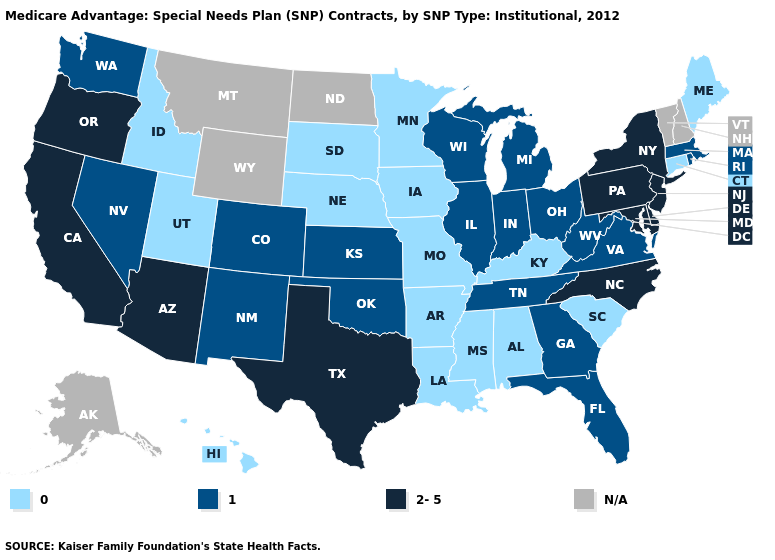What is the value of Nebraska?
Keep it brief. 0. What is the value of Mississippi?
Quick response, please. 0. Which states have the lowest value in the Northeast?
Be succinct. Connecticut, Maine. Name the states that have a value in the range 2-5?
Short answer required. Arizona, California, Delaware, Maryland, North Carolina, New Jersey, New York, Oregon, Pennsylvania, Texas. Name the states that have a value in the range N/A?
Quick response, please. Alaska, Montana, North Dakota, New Hampshire, Vermont, Wyoming. What is the value of New Jersey?
Answer briefly. 2-5. What is the value of South Carolina?
Concise answer only. 0. Name the states that have a value in the range N/A?
Keep it brief. Alaska, Montana, North Dakota, New Hampshire, Vermont, Wyoming. Is the legend a continuous bar?
Short answer required. No. Name the states that have a value in the range 0?
Quick response, please. Alabama, Arkansas, Connecticut, Hawaii, Iowa, Idaho, Kentucky, Louisiana, Maine, Minnesota, Missouri, Mississippi, Nebraska, South Carolina, South Dakota, Utah. What is the highest value in the USA?
Be succinct. 2-5. What is the value of Vermont?
Concise answer only. N/A. Which states have the lowest value in the USA?
Keep it brief. Alabama, Arkansas, Connecticut, Hawaii, Iowa, Idaho, Kentucky, Louisiana, Maine, Minnesota, Missouri, Mississippi, Nebraska, South Carolina, South Dakota, Utah. Name the states that have a value in the range 0?
Quick response, please. Alabama, Arkansas, Connecticut, Hawaii, Iowa, Idaho, Kentucky, Louisiana, Maine, Minnesota, Missouri, Mississippi, Nebraska, South Carolina, South Dakota, Utah. What is the highest value in the MidWest ?
Concise answer only. 1. 